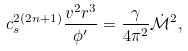Convert formula to latex. <formula><loc_0><loc_0><loc_500><loc_500>c _ { s } ^ { 2 ( 2 n + 1 ) } \frac { v ^ { 2 } r ^ { 3 } } { \phi ^ { \prime } } = \frac { \gamma } { 4 \pi ^ { 2 } } \dot { \mathcal { M } } ^ { 2 } ,</formula> 